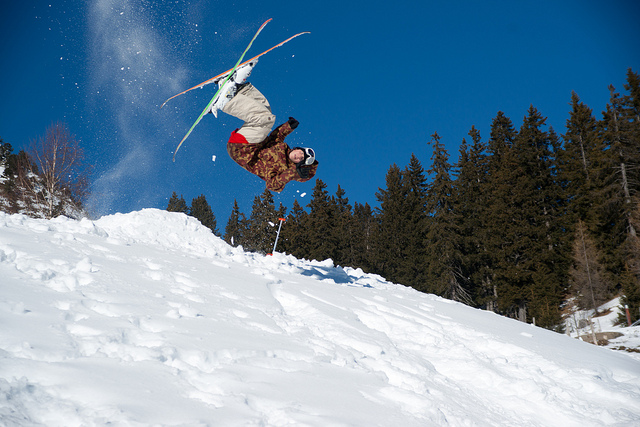<image>Where are the trees' shadows? It is ambiguous where the trees' shadows are. They could be on the snow, on the side of the hill, in the forest, or behind the trees. Where are the trees' shadows? I am not sure where the trees' shadows are. It is possible that they are behind the trees. 